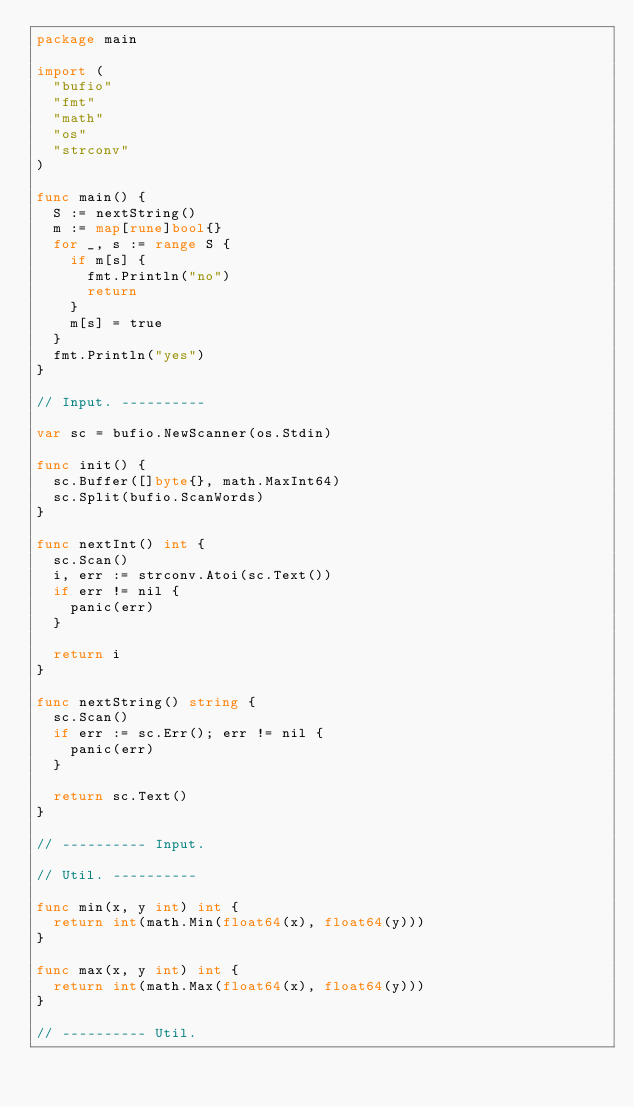<code> <loc_0><loc_0><loc_500><loc_500><_Go_>package main

import (
	"bufio"
	"fmt"
	"math"
	"os"
	"strconv"
)

func main() {
	S := nextString()
	m := map[rune]bool{}
	for _, s := range S {
		if m[s] {
			fmt.Println("no")
			return
		}
		m[s] = true
	}
	fmt.Println("yes")
}

// Input. ----------

var sc = bufio.NewScanner(os.Stdin)

func init() {
	sc.Buffer([]byte{}, math.MaxInt64)
	sc.Split(bufio.ScanWords)
}

func nextInt() int {
	sc.Scan()
	i, err := strconv.Atoi(sc.Text())
	if err != nil {
		panic(err)
	}

	return i
}

func nextString() string {
	sc.Scan()
	if err := sc.Err(); err != nil {
		panic(err)
	}

	return sc.Text()
}

// ---------- Input.

// Util. ----------

func min(x, y int) int {
	return int(math.Min(float64(x), float64(y)))
}

func max(x, y int) int {
	return int(math.Max(float64(x), float64(y)))
}

// ---------- Util.
</code> 